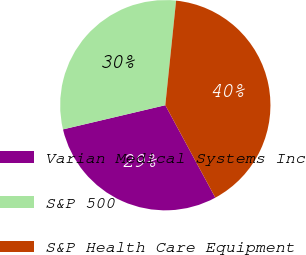Convert chart to OTSL. <chart><loc_0><loc_0><loc_500><loc_500><pie_chart><fcel>Varian Medical Systems Inc<fcel>S&P 500<fcel>S&P Health Care Equipment<nl><fcel>29.2%<fcel>30.33%<fcel>40.47%<nl></chart> 